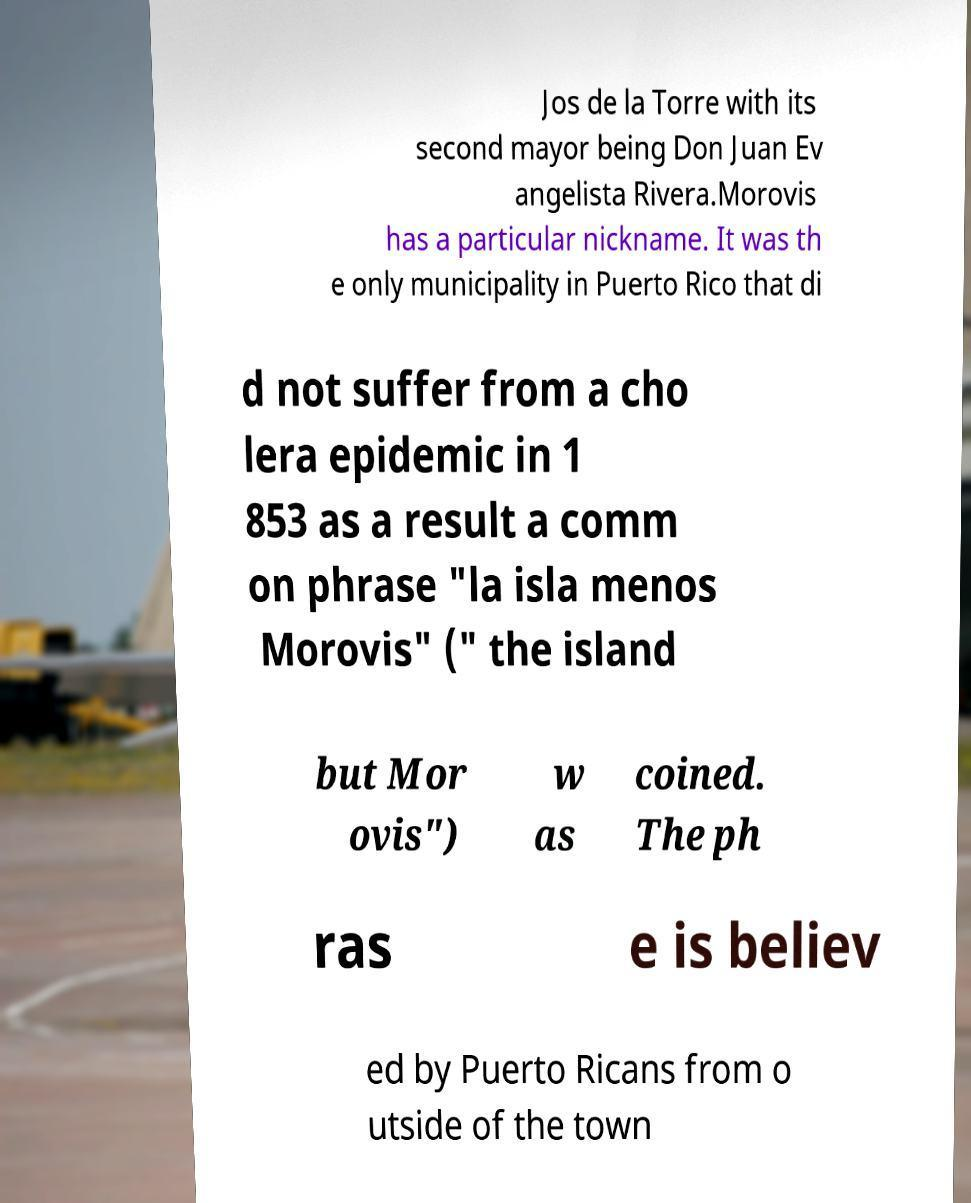What messages or text are displayed in this image? I need them in a readable, typed format. Jos de la Torre with its second mayor being Don Juan Ev angelista Rivera.Morovis has a particular nickname. It was th e only municipality in Puerto Rico that di d not suffer from a cho lera epidemic in 1 853 as a result a comm on phrase "la isla menos Morovis" (" the island but Mor ovis") w as coined. The ph ras e is believ ed by Puerto Ricans from o utside of the town 